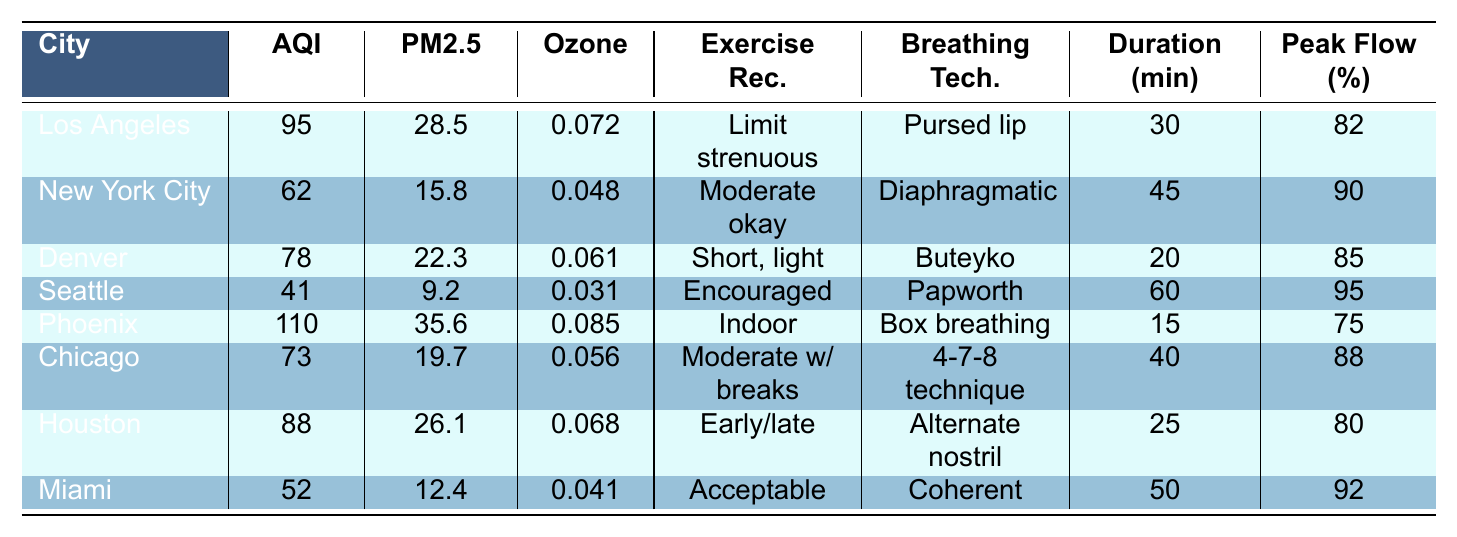What's the Air Quality Index (AQI) for Miami? The AQI for Miami is listed directly in the table under the "AQI" column for Miami, which shows a value of 52.
Answer: 52 What is the recommended breathing technique for Denver? The recommended breathing technique for Denver is shown in the table in the "Breathing Tech." column, which specifies the Buteyko method.
Answer: Buteyko method Which city has the highest Particulate Matter (PM2.5) level? By examining the "Particulate Matter (PM2.5)" column in the table, Phoenix has the highest value at 35.6, compared to other cities listed.
Answer: Phoenix Is outdoor exercise encouraged in Seattle? The table indicates "Outdoor exercise encouraged" for Seattle under the "Exercise Rec." column, confirming that outdoor exercise is advised.
Answer: Yes What is the average suggested exercise duration for cities with AQI below 80? The cities with AQI below 80 are Seattle (60 minutes), New York City (45 minutes), and Miami (50 minutes). Thus, the average is (60 + 45 + 50) / 3 = 155 / 3 = 51.67 minutes.
Answer: 51.67 minutes What city's exercise recommendation suggests indoor exercise? From the table, Phoenix is the only city that recommends indoor exercise, indicated in the "Exercise Rec." column.
Answer: Phoenix What is the difference in AQI between Los Angeles and Chicago? The AQI for Los Angeles is 95, and for Chicago it is 73. The difference is 95 - 73 = 22.
Answer: 22 Which breathing technique is recommended for individuals in Houston? The recommended breathing technique for Houston is found in the "Breathing Tech." column, indicating that it is alternate nostril breathing.
Answer: Alternate nostril breathing How many cities recommend outdoor exercise for a duration of 60 minutes or more? The cities recommending 60 minutes or more of outdoor exercise are Seattle (60 minutes) and Miami (50 minutes), thus only Seattle qualifies.
Answer: 1 city What is the average Peak Flow Meter Reading for cities with an AQI above 80? The cities with AQI above 80 are Los Angeles (82), Phoenix (75), and Houston (80), with an average reading calculated as (82 + 75 + 80) / 3 = 237 / 3 = 79.
Answer: 79 